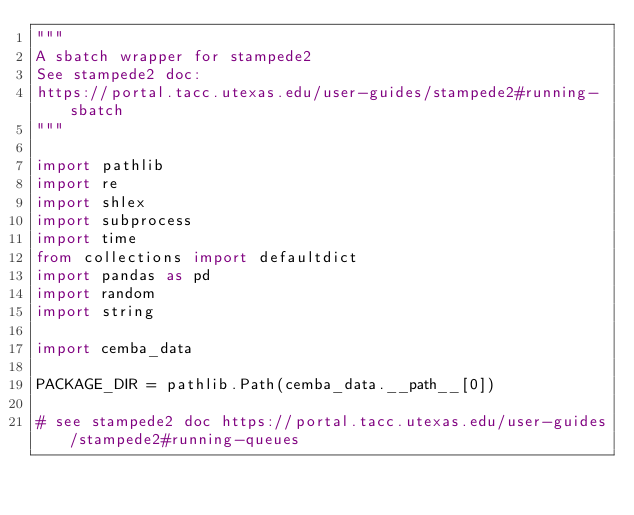Convert code to text. <code><loc_0><loc_0><loc_500><loc_500><_Python_>"""
A sbatch wrapper for stampede2
See stampede2 doc:
https://portal.tacc.utexas.edu/user-guides/stampede2#running-sbatch
"""

import pathlib
import re
import shlex
import subprocess
import time
from collections import defaultdict
import pandas as pd
import random
import string

import cemba_data

PACKAGE_DIR = pathlib.Path(cemba_data.__path__[0])

# see stampede2 doc https://portal.tacc.utexas.edu/user-guides/stampede2#running-queues</code> 